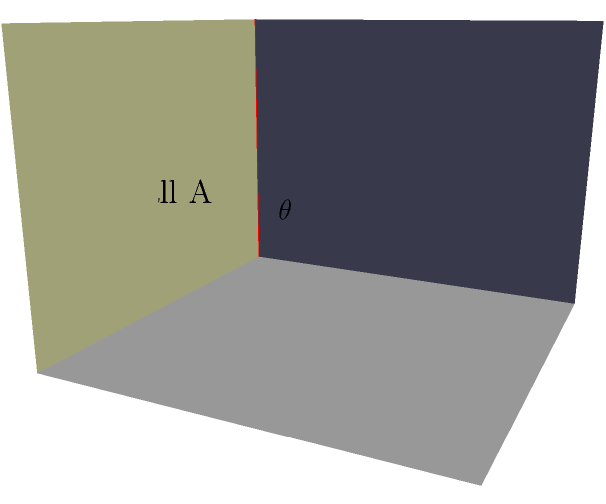In a luxurious suite, you need to photograph the intersection of two perpendicular walls. The first wall (Wall A) measures 4 meters wide and 3 meters high, while the second wall (Wall B) is 4 meters long and 3 meters high. What is the angle $\theta$ between these two walls? To determine the angle between two perpendicular walls, we can follow these steps:

1. Recognize that the walls are perpendicular to each other, forming a right angle.
2. Recall that a right angle measures 90 degrees.
3. In three-dimensional space, perpendicular walls intersect at a 90-degree angle, regardless of their individual dimensions.
4. The angle $\theta$ between the two walls is therefore equal to 90 degrees.

This 90-degree angle is crucial in architectural photography, as it creates clean lines and a sense of structure in the composition. When capturing luxury hotel interiors, this right angle can be used to create a feeling of spaciousness and elegance in the image.
Answer: $90^\circ$ 